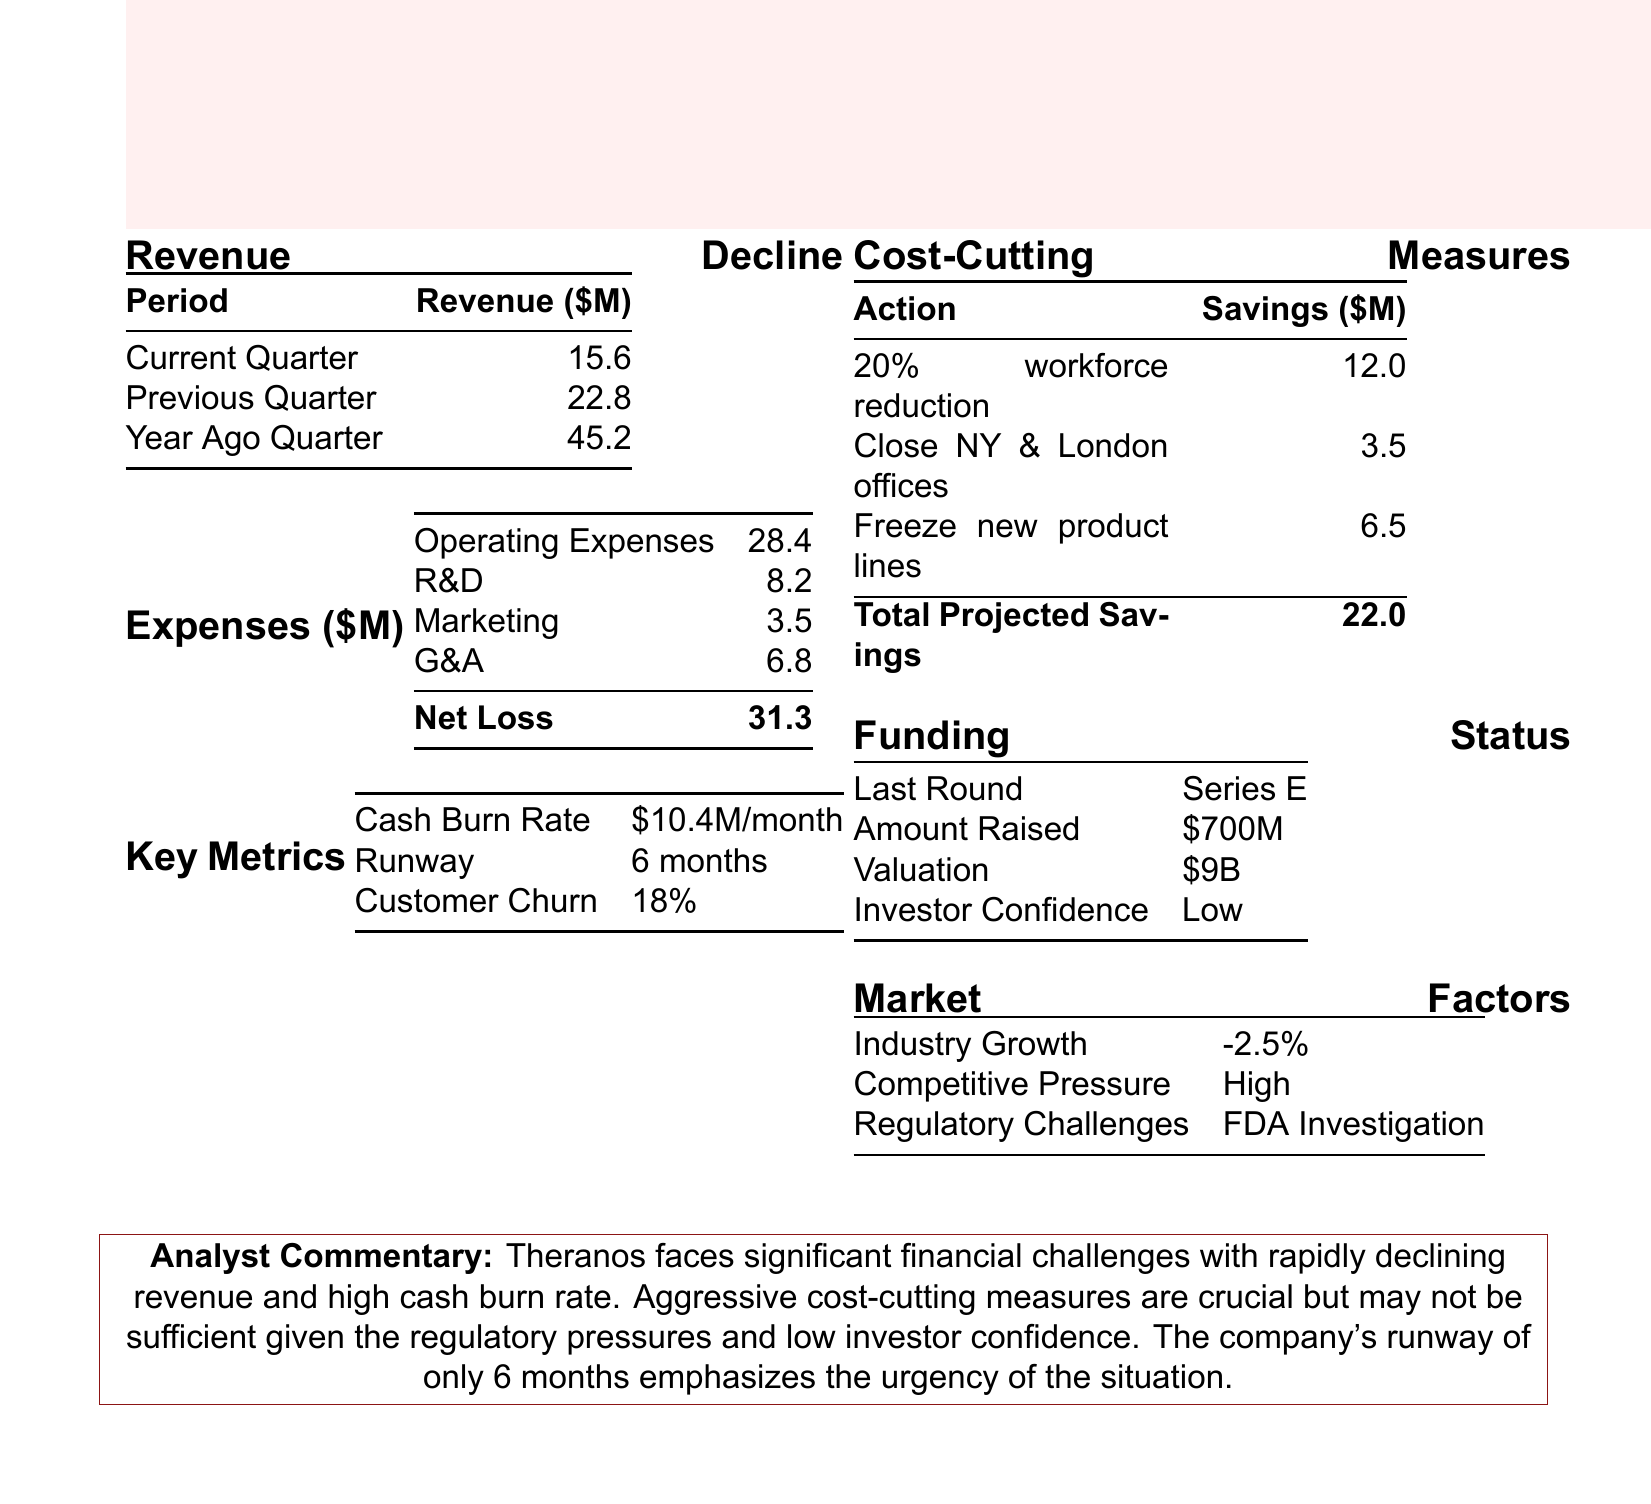What is the current quarter revenue? The current quarter revenue is listed directly in the document under Revenue Decline.
Answer: 15.6 What was the revenue a year ago? The revenue a year ago is directly stated in the document.
Answer: 45.2 What is the total projected savings from cost-cutting measures? The total projected savings is displayed at the bottom of the Cost-Cutting Measures section.
Answer: 22.0 What is the company's cash burn rate? The cash burn rate is mentioned in the Key Metrics section.
Answer: 10.4M/month What is the company's runway? The runway is specified in the Key Metrics section.
Answer: 6 months What significant challenge is posed by regulators? The regulatory challenge is indicated in the Market Factors section.
Answer: FDA Investigation How much was raised in the last funding round? The amount raised in the last funding round is stated in the Funding Status section.
Answer: 700M What is the operating expense amount? The operating expenses amount is listed in the Expenses section.
Answer: 28.4 What is the calculated net loss? The net loss is shown clearly in the Expenses section.
Answer: 31.3 